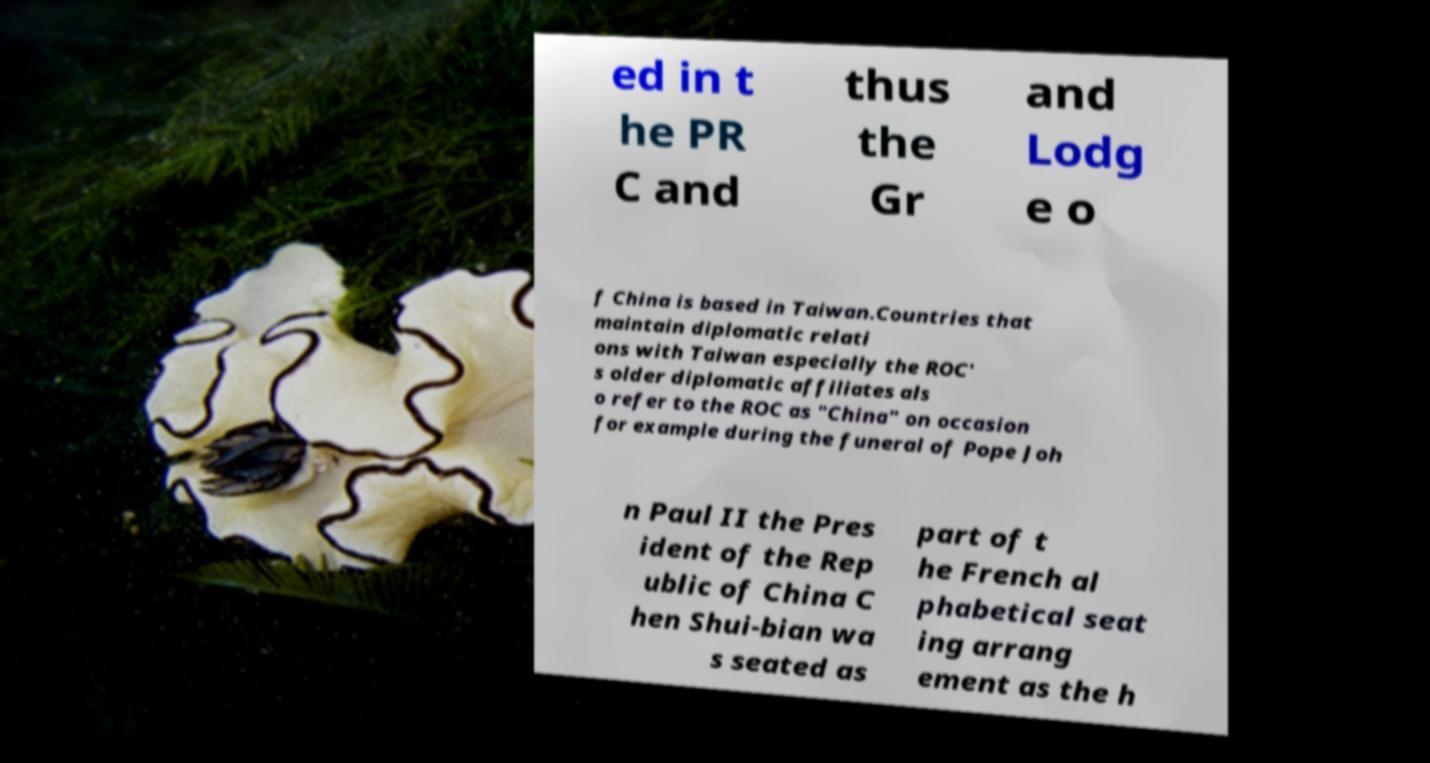Please identify and transcribe the text found in this image. ed in t he PR C and thus the Gr and Lodg e o f China is based in Taiwan.Countries that maintain diplomatic relati ons with Taiwan especially the ROC' s older diplomatic affiliates als o refer to the ROC as "China" on occasion for example during the funeral of Pope Joh n Paul II the Pres ident of the Rep ublic of China C hen Shui-bian wa s seated as part of t he French al phabetical seat ing arrang ement as the h 